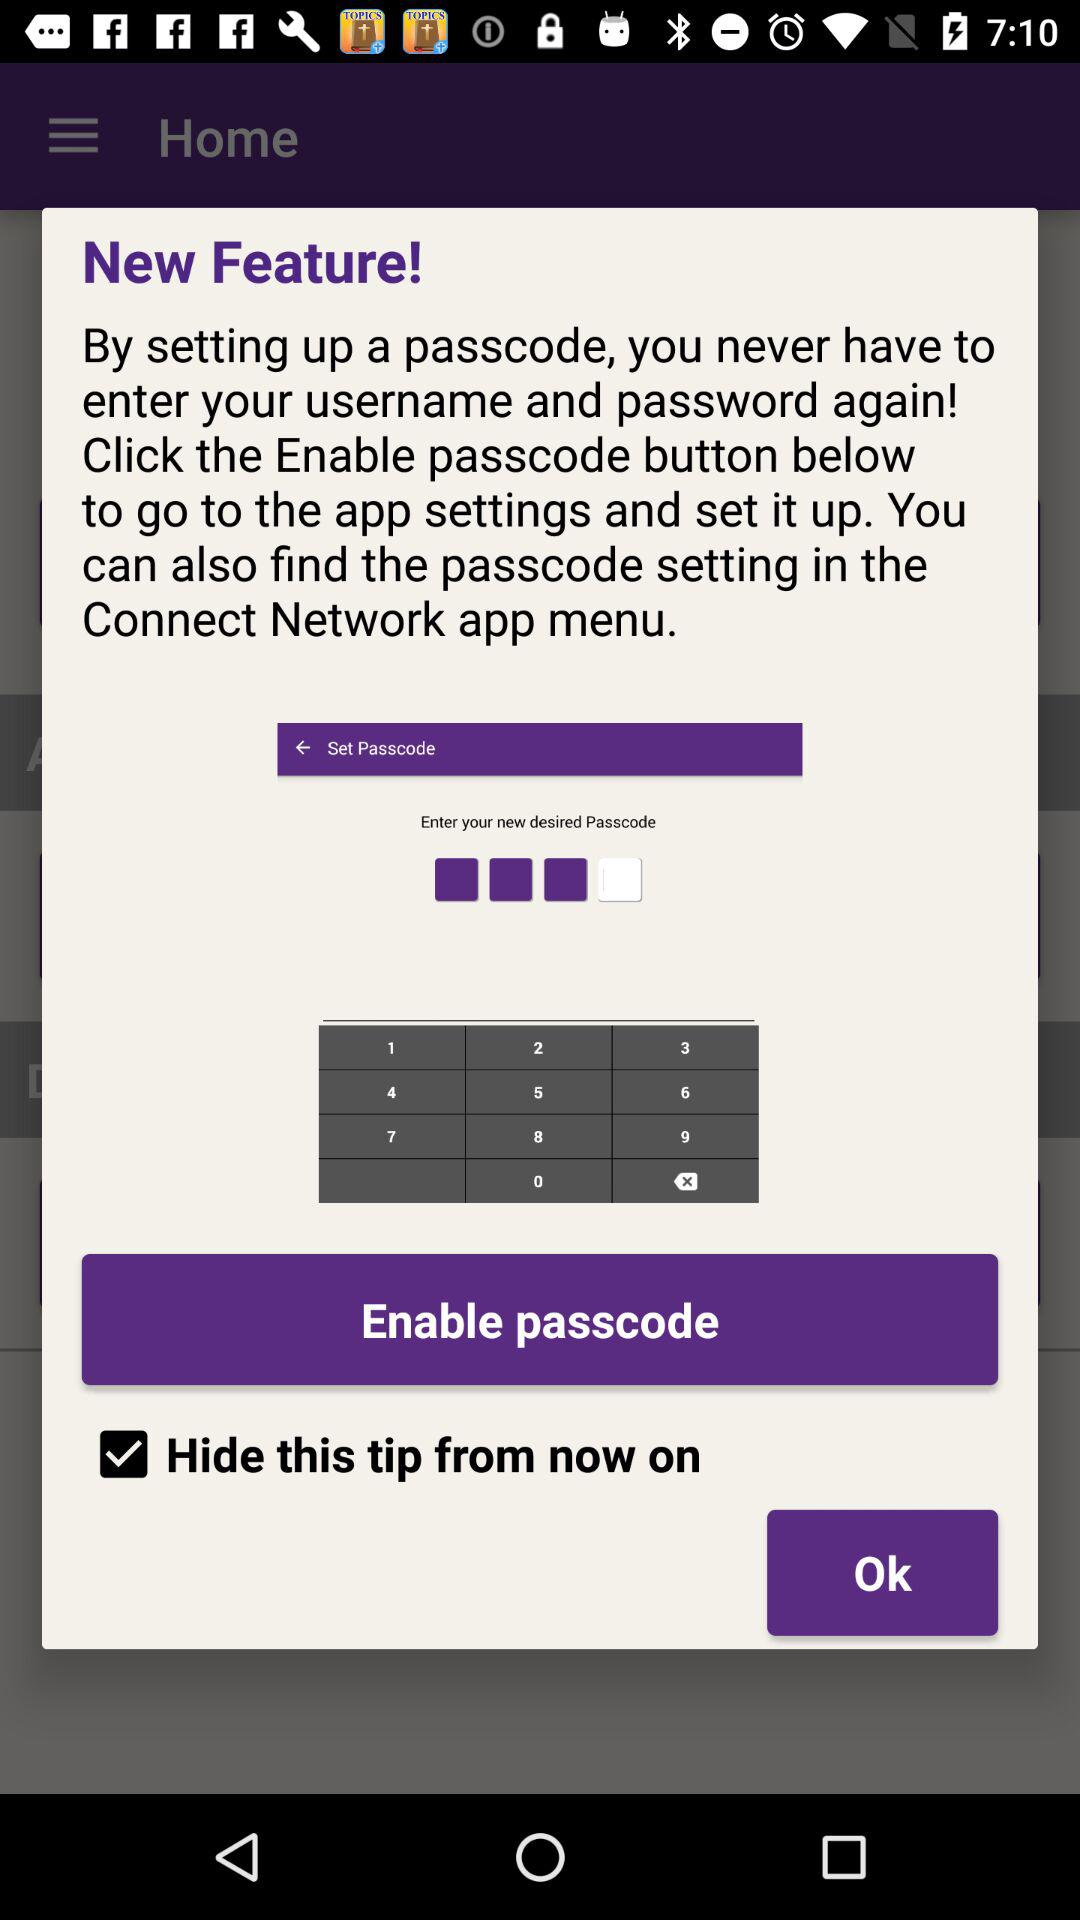What is the entered passcode?
When the provided information is insufficient, respond with <no answer>. <no answer> 